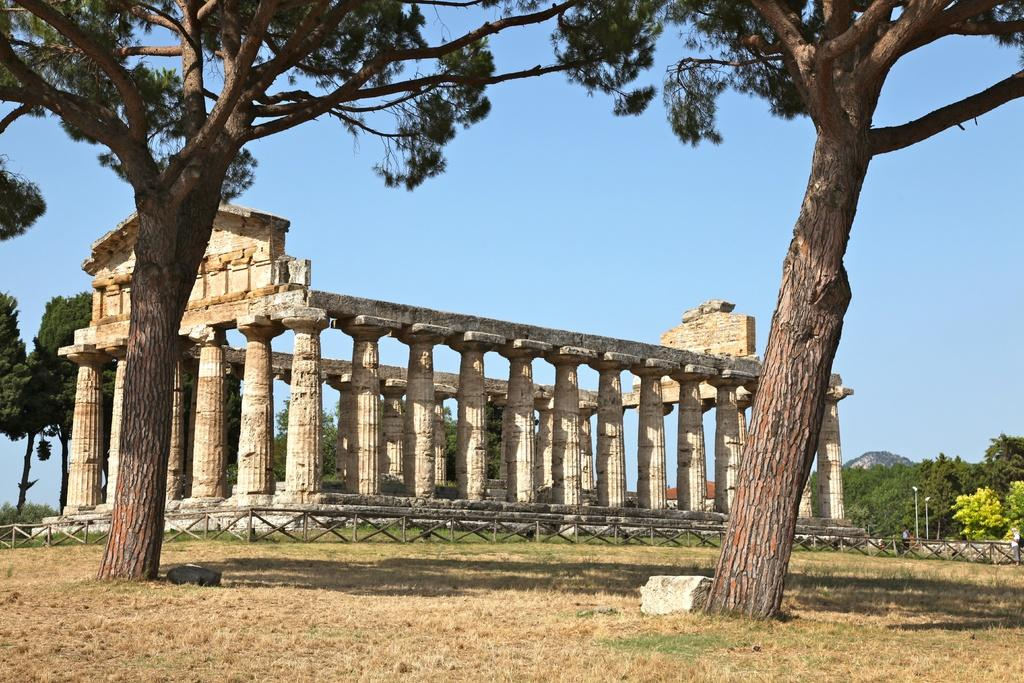What type of building is depicted in the image? There is a temple of Athena in the image. What can be seen on either side of the temple? There is a tree on either side of the temple. What else can be seen in the background of the image? There are additional trees in the background of the image. What type of body is present in the image? There is no body present in the image; it features a temple of Athena and trees. What does the shade of the trees provide in the image? The image does not show the shade of the trees, as it only depicts the temple and trees themselves. 